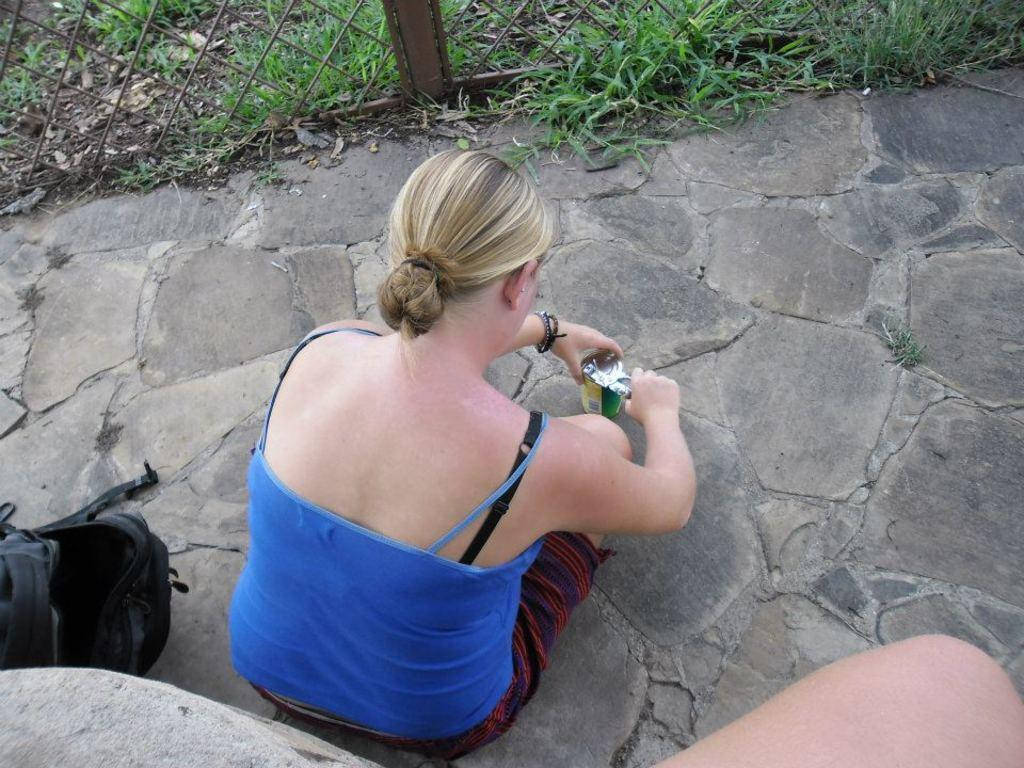How many people are in the image? There are people in the image. Can you describe the woman in the image? There is a woman in the image, and she is holding a cup. What else can be seen in the image besides the people? There is a bag, a fence, and grass visible in the image. Where is the rabbit sleeping in the image? There is no rabbit present in the image. What type of haircut does the woman have in the image? The provided facts do not mention the woman's haircut, so it cannot be determined from the image. 